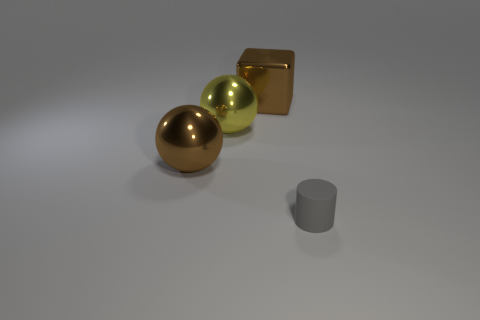What number of brown objects are either large blocks or big things?
Make the answer very short. 2. What is the color of the large block that is the same material as the yellow sphere?
Provide a succinct answer. Brown. There is a matte cylinder; is its color the same as the metallic ball on the right side of the brown shiny sphere?
Provide a short and direct response. No. There is a thing that is both to the left of the large brown cube and in front of the large yellow shiny ball; what color is it?
Ensure brevity in your answer.  Brown. There is a big brown sphere; what number of large metal things are in front of it?
Make the answer very short. 0. What number of things are either large metallic balls or big brown metallic objects behind the yellow object?
Keep it short and to the point. 3. There is a big brown metal thing that is to the left of the large metal cube; are there any metallic objects that are to the right of it?
Your response must be concise. Yes. There is a thing right of the metal block; what color is it?
Provide a succinct answer. Gray. Are there an equal number of gray matte cylinders behind the yellow metallic sphere and yellow spheres?
Provide a short and direct response. No. What shape is the object that is both behind the gray cylinder and to the right of the yellow object?
Provide a short and direct response. Cube. 